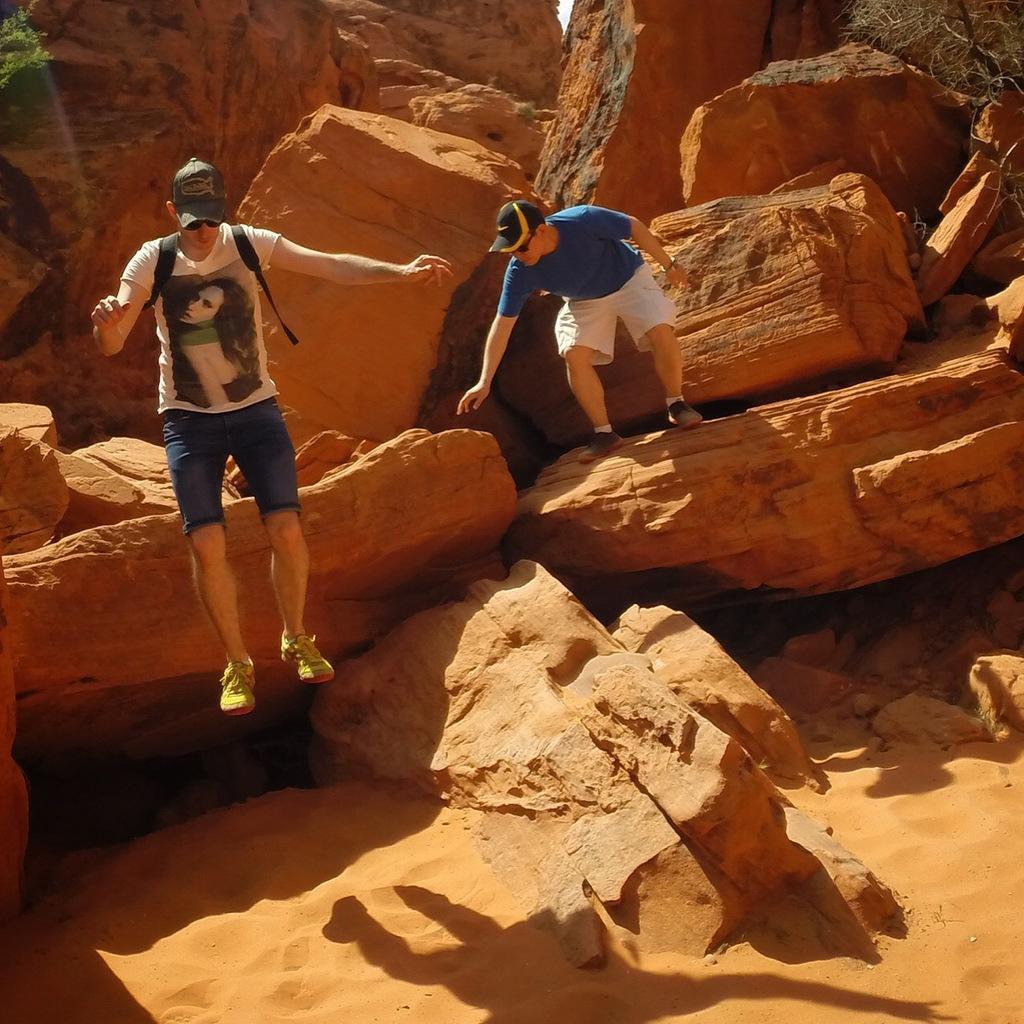How would you summarize this image in a sentence or two? This is an outside view. In this image I can see many rocks. At the bottom there is sand. On the left side there is a man jumping and there is another man standing on a rock. 